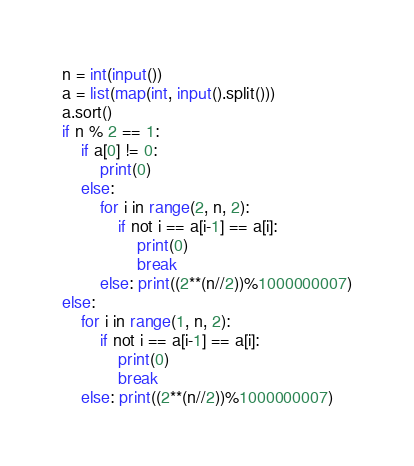Convert code to text. <code><loc_0><loc_0><loc_500><loc_500><_Python_>n = int(input())
a = list(map(int, input().split()))
a.sort()
if n % 2 == 1:
    if a[0] != 0:
        print(0)
    else:
        for i in range(2, n, 2):
            if not i == a[i-1] == a[i]:
                print(0)
                break
        else: print((2**(n//2))%1000000007)
else:
    for i in range(1, n, 2):
        if not i == a[i-1] == a[i]:
            print(0)
            break
    else: print((2**(n//2))%1000000007)</code> 